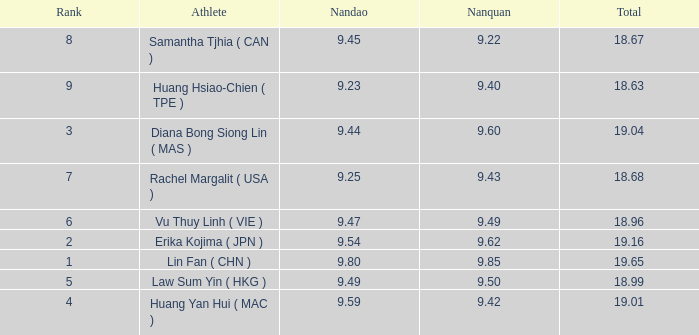Which Nanquan has a Nandao larger than 9.49, and a Rank of 4? 9.42. 